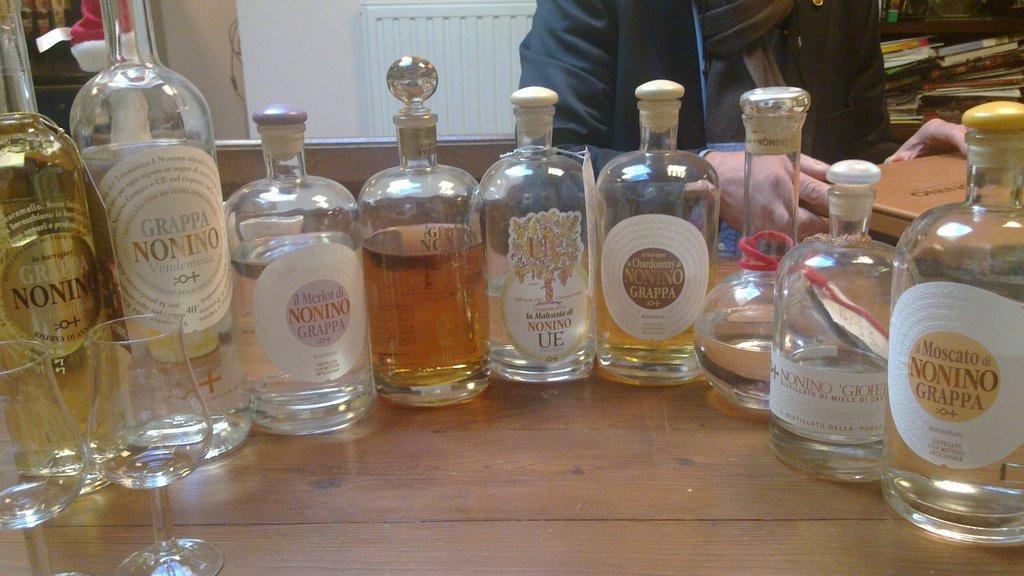What type of containers can be seen in the image? There are bottles and glasses in the image. What might these containers be used for? These containers might be used for holding or serving liquids. Can you describe any human presence in the image? Yes, there is a hand of a person visible in the background of the image. What type of feast is being prepared in the image? There is no indication of a feast or any food preparation in the image; it only shows bottles, glasses, and a hand. 